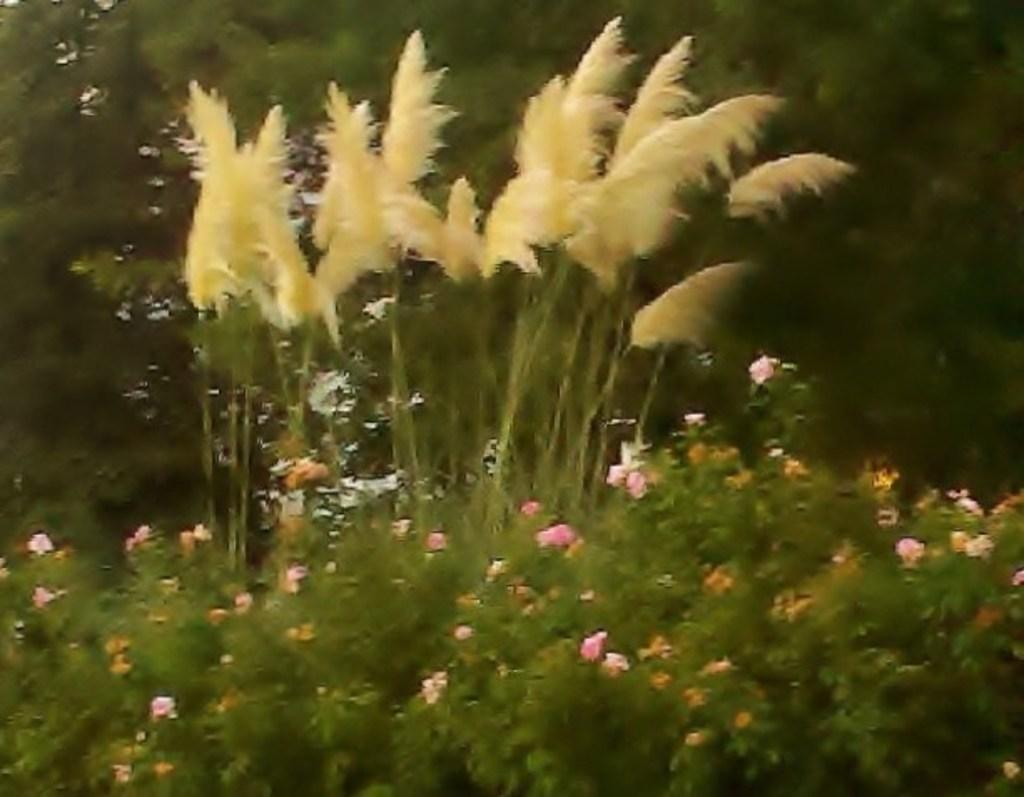What type of plants can be seen in the image? There are flower plants in the image. What joke is the flower plant telling in the image? Flower plants do not tell jokes; they are inanimate objects. 